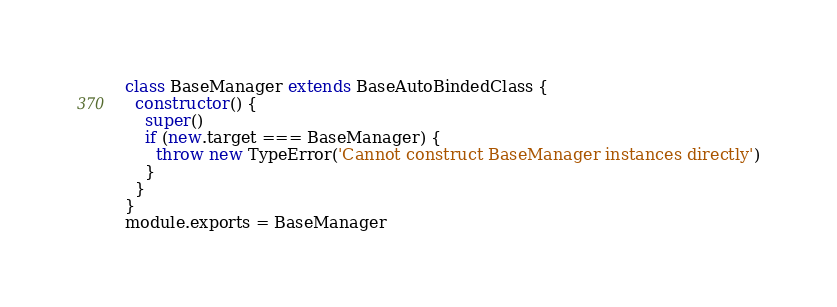Convert code to text. <code><loc_0><loc_0><loc_500><loc_500><_JavaScript_>
class BaseManager extends BaseAutoBindedClass {
  constructor() {
    super()
    if (new.target === BaseManager) {
      throw new TypeError('Cannot construct BaseManager instances directly')
    }
  }
}
module.exports = BaseManager
</code> 